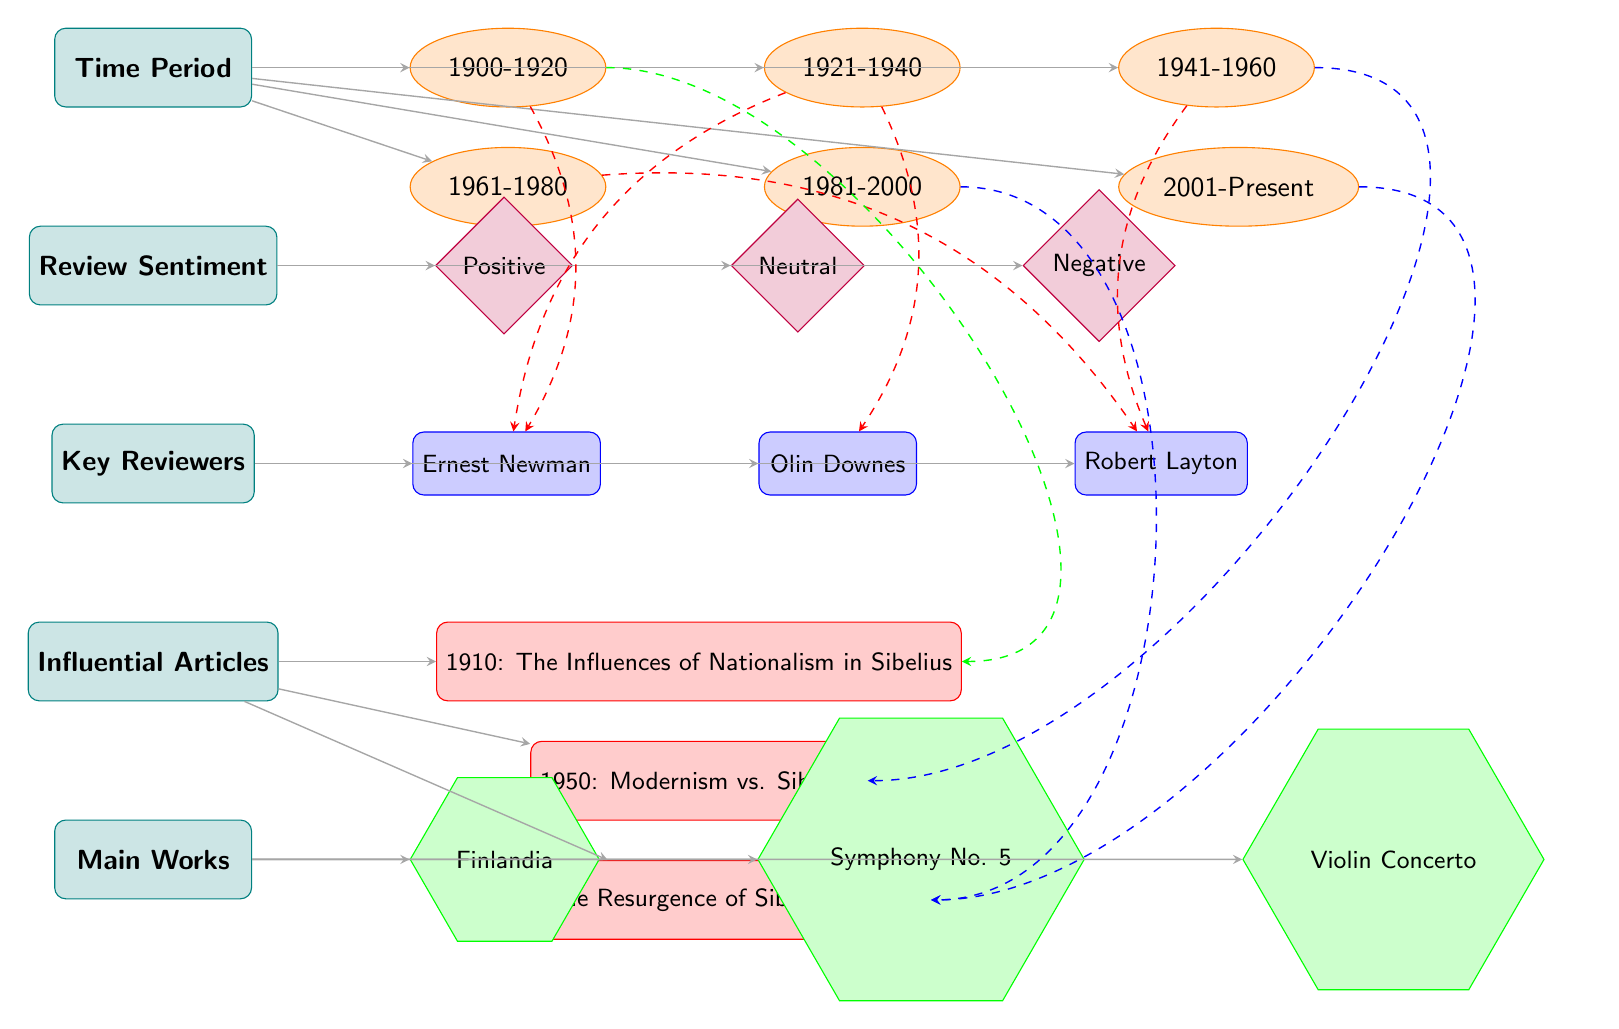What time period is associated with the composition Finlandia? The diagram connects the composition Finlandia to the time period node, which is represented by the time period 1900-1920. Therefore, Finlandia is associated with this time period.
Answer: 1900-1920 How many key reviewers are listed in the diagram? The diagram lists three reviewers, which are Ernest Newman, Olin Downes, and Robert Layton. There are three edges connecting the reviewers category to the reviewer nodes.
Answer: 3 Which article discusses the influences of nationalism in Sibelius? The article node indicates that the article titled "1910: The Influences of Nationalism in Sibelius" is directly associated with the category of influential articles.
Answer: 1910: The Influences of Nationalism in Sibelius What sentiment is associated with the reviews in the time period 1921-1940? Sentiment from the reviews during that time period can be positive, neutral, or negative. The relationships will lead to the sentiment nodes, which are directly linked but don't specify the dominant sentiment for that period in the diagram. Without additional data, we don’t know which sentiment is dominant.
Answer: Not specified Which composition is related to the negative sentiment in the 1961-1980 period? To find this, one would trace the edges: the negative sentiment node connects to the works category, but there are no specific compositions shown to have a negative sentiment for this period in the diagram. Thus, the precise composition related to this sentiment is not defined.
Answer: Not specified 